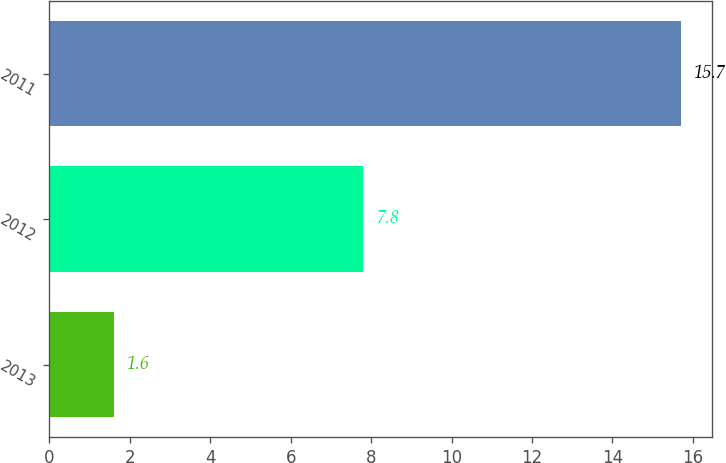<chart> <loc_0><loc_0><loc_500><loc_500><bar_chart><fcel>2013<fcel>2012<fcel>2011<nl><fcel>1.6<fcel>7.8<fcel>15.7<nl></chart> 